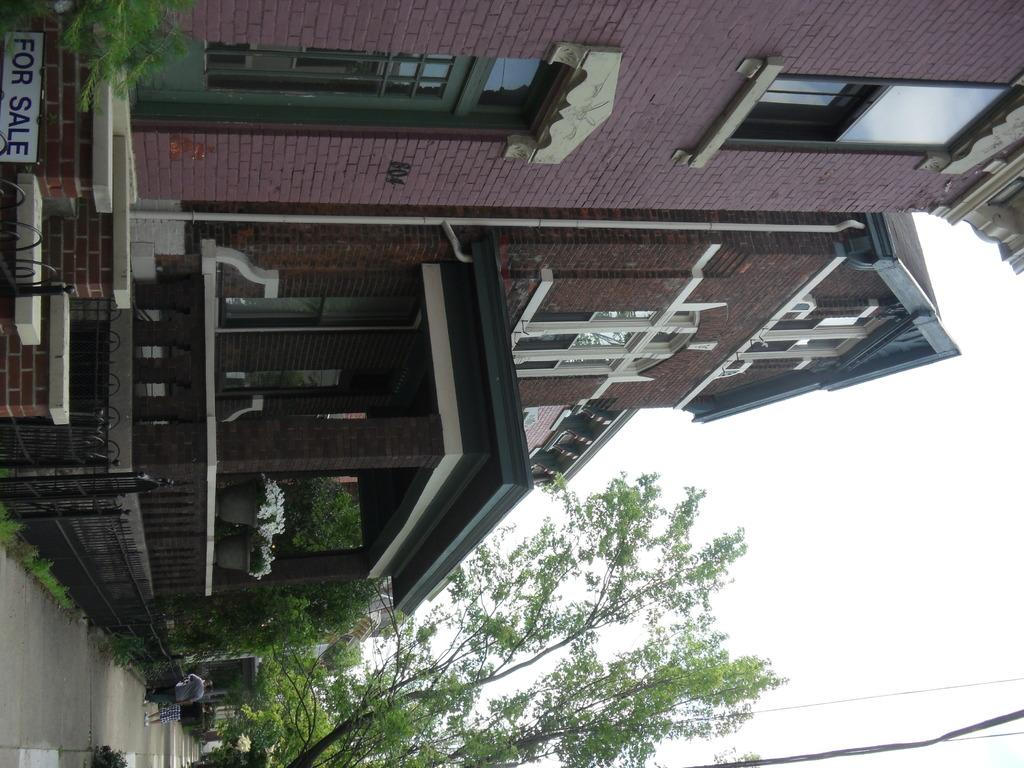What is the main feature of the picture? There is a road in the picture. Are there any people present in the image? Yes, there are people standing in the picture. What type of natural elements can be seen in the picture? There are trees in the picture. What type of structures are visible in the image? There are houses in the picture. What is the condition of the sky in the picture? The sky is clear in the picture. Can you tell me where the river is located in the picture? There is no river present in the image. What type of handshake is being exchanged between the people in the picture? There is no handshake or meeting taking place in the image; people are simply standing. 